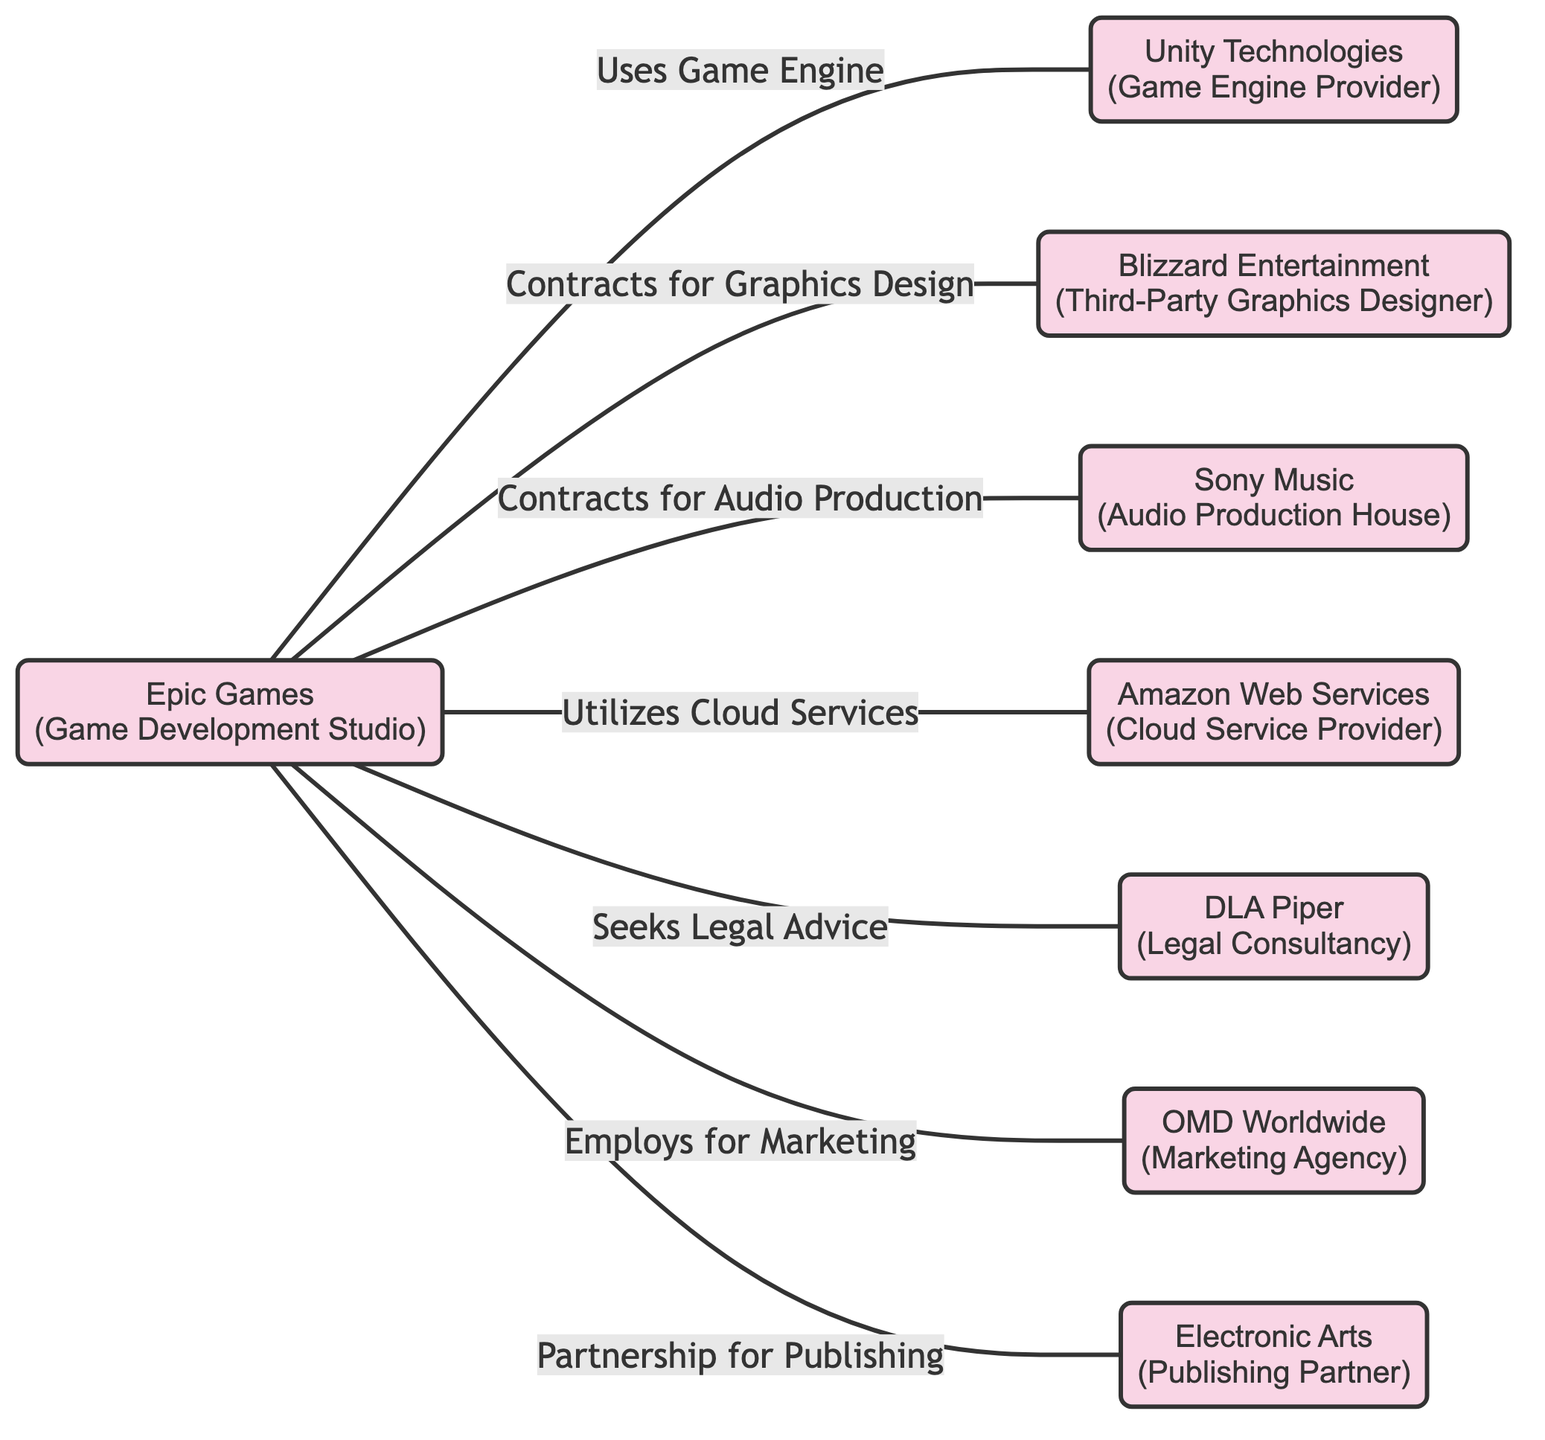What is the total number of companies represented in the diagram? The diagram lists eight distinct companies represented as nodes. Each company is indicated by a unique identifier (id) ranging from 1 to 8.
Answer: 8 Which company is partnered with Epic Games for audio production? The edge labeled "Contracts for Audio Production" connects Epic Games (node 1) to Sony Music (node 4), indicating that Sony Music is the partner for audio production.
Answer: Sony Music What type of relationship does Epic Games have with Amazon Web Services? The edge labeled "Utilizes Cloud Services" indicates that Epic Games (node 1) has a relationship with Amazon Web Services (node 5) involving the utilization of cloud services.
Answer: Utilizes Cloud Services How many different types of relationships connect Epic Games to other companies? There are seven relationships depicted (one to each of the other nodes), signifying that Epic Games has various interactions with other entities in different areas such as marketing, legal advice, and more.
Answer: 7 Which company does Epic Games seek legal advice from? The edge labeled "Seeks Legal Advice" links Epic Games (node 1) to DLA Piper (node 6), indicating that DLA Piper provides legal consultancy to Epic Games.
Answer: DLA Piper Are there any third-party companies involved in the partnerships of Epic Games? The diagram shows that Blizzard Entertainment (node 3) and Sony Music (node 4) are third-party companies involved in graphics design and audio production, respectively, for Epic Games.
Answer: Yes What is the relationship between Epic Games and Unity Technologies? The edge labeled "Uses Game Engine" illustrates that Epic Games (node 1) utilizes the game engine provided by Unity Technologies (node 2).
Answer: Uses Game Engine How many contracts does Epic Games have with third-party entities for services? Epic Games has contracts for graphics design (with Blizzard Entertainment), audio production (with Sony Music), marketing (with OMD Worldwide), and relationships for publishing (with Electronic Arts), totaling four distinct contracts with third-party entities.
Answer: 4 Which company is the publishing partner of Epic Games? The edge labeled "Partnership for Publishing" indicates that Electronic Arts (node 8) is partnered with Epic Games (node 1) for publishing services.
Answer: Electronic Arts 